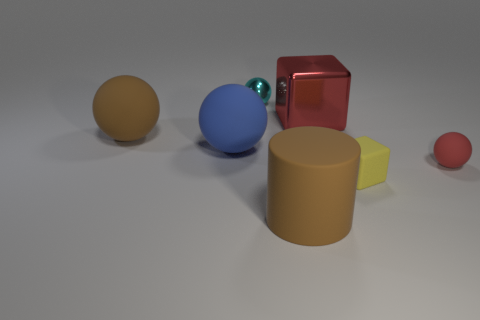What number of other things are the same shape as the tiny red object?
Provide a short and direct response. 3. Is the tiny cyan thing the same shape as the big blue rubber object?
Provide a succinct answer. Yes. What is the size of the rubber thing right of the small cube?
Give a very brief answer. Small. There is a red object that is the same size as the matte cylinder; what is it made of?
Offer a very short reply. Metal. Is the number of cylinders greater than the number of large red matte cylinders?
Your response must be concise. Yes. There is a brown matte object behind the thing to the right of the small yellow rubber thing; what size is it?
Provide a succinct answer. Large. The red object that is the same size as the cyan ball is what shape?
Ensure brevity in your answer.  Sphere. The large brown rubber thing that is right of the brown rubber object on the left side of the big brown thing that is in front of the blue sphere is what shape?
Ensure brevity in your answer.  Cylinder. Does the block in front of the large red thing have the same color as the large metallic block that is behind the small yellow block?
Your answer should be compact. No. How many small blue balls are there?
Keep it short and to the point. 0. 